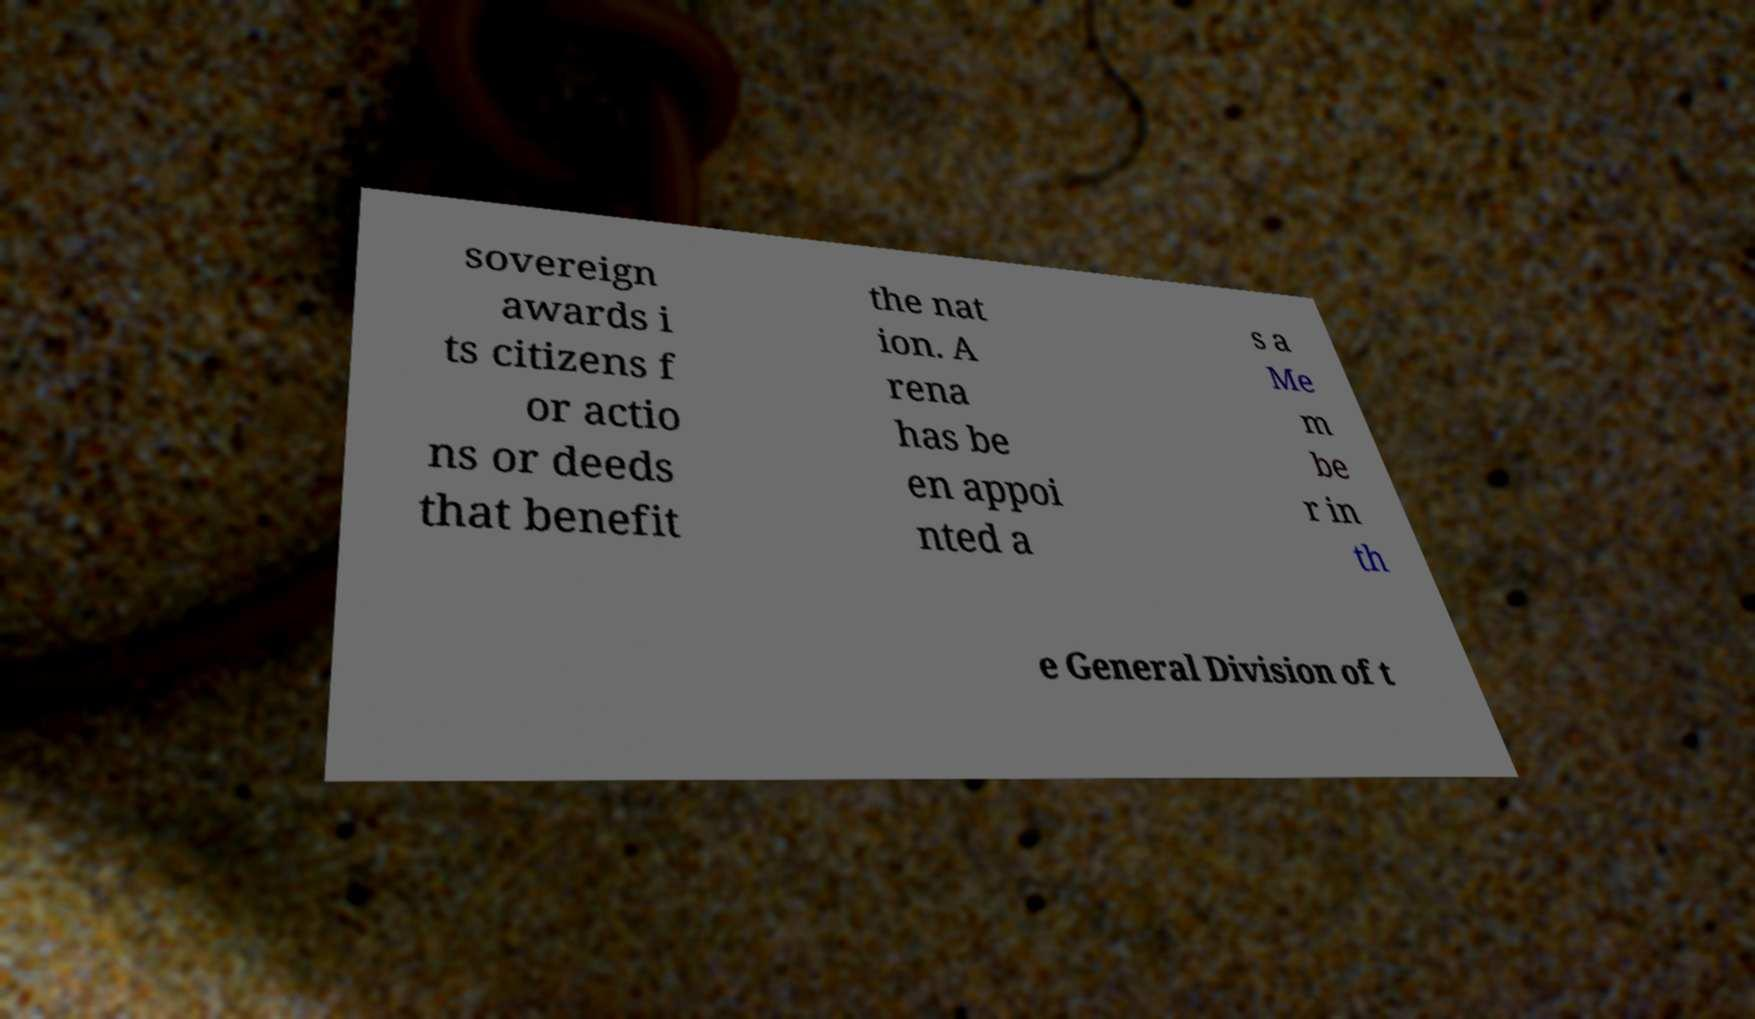Please read and relay the text visible in this image. What does it say? sovereign awards i ts citizens f or actio ns or deeds that benefit the nat ion. A rena has be en appoi nted a s a Me m be r in th e General Division of t 